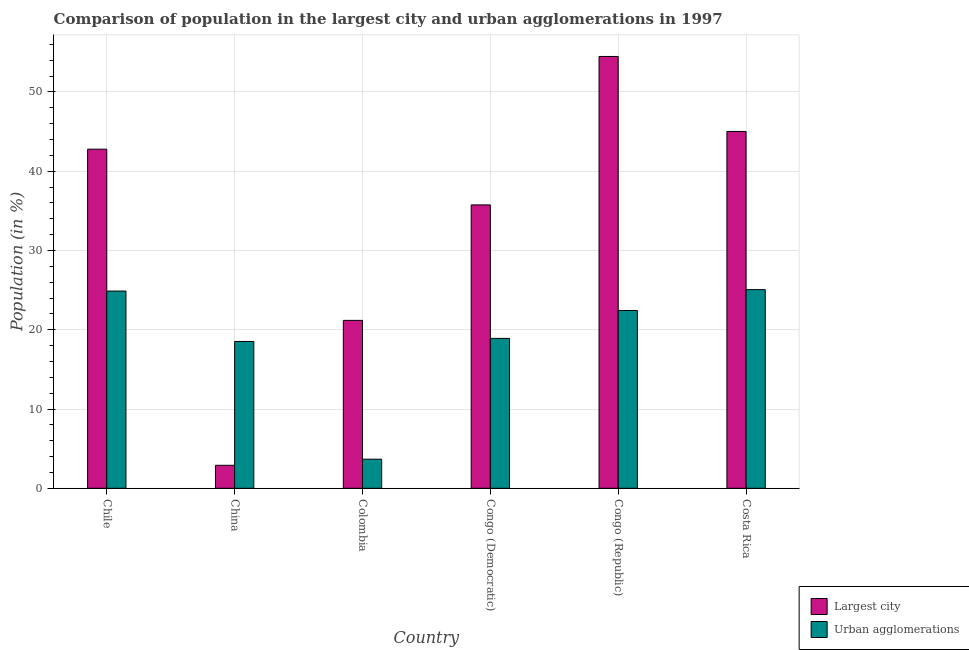Are the number of bars on each tick of the X-axis equal?
Keep it short and to the point. Yes. How many bars are there on the 6th tick from the right?
Provide a succinct answer. 2. What is the label of the 5th group of bars from the left?
Keep it short and to the point. Congo (Republic). In how many cases, is the number of bars for a given country not equal to the number of legend labels?
Your response must be concise. 0. What is the population in the largest city in Chile?
Ensure brevity in your answer.  42.78. Across all countries, what is the maximum population in urban agglomerations?
Ensure brevity in your answer.  25.06. Across all countries, what is the minimum population in the largest city?
Give a very brief answer. 2.9. In which country was the population in urban agglomerations maximum?
Ensure brevity in your answer.  Costa Rica. In which country was the population in urban agglomerations minimum?
Your response must be concise. Colombia. What is the total population in urban agglomerations in the graph?
Offer a very short reply. 113.47. What is the difference between the population in the largest city in Congo (Democratic) and that in Costa Rica?
Provide a succinct answer. -9.27. What is the difference between the population in the largest city in China and the population in urban agglomerations in Chile?
Offer a very short reply. -21.98. What is the average population in urban agglomerations per country?
Your answer should be compact. 18.91. What is the difference between the population in urban agglomerations and population in the largest city in Costa Rica?
Keep it short and to the point. -19.95. What is the ratio of the population in urban agglomerations in Congo (Democratic) to that in Costa Rica?
Keep it short and to the point. 0.75. Is the population in the largest city in Colombia less than that in Costa Rica?
Give a very brief answer. Yes. Is the difference between the population in the largest city in Chile and China greater than the difference between the population in urban agglomerations in Chile and China?
Your answer should be compact. Yes. What is the difference between the highest and the second highest population in urban agglomerations?
Provide a succinct answer. 0.18. What is the difference between the highest and the lowest population in the largest city?
Your answer should be very brief. 51.57. In how many countries, is the population in urban agglomerations greater than the average population in urban agglomerations taken over all countries?
Provide a succinct answer. 3. What does the 2nd bar from the left in Chile represents?
Your response must be concise. Urban agglomerations. What does the 2nd bar from the right in Congo (Republic) represents?
Your answer should be very brief. Largest city. How many bars are there?
Give a very brief answer. 12. Are all the bars in the graph horizontal?
Ensure brevity in your answer.  No. How many countries are there in the graph?
Your response must be concise. 6. What is the difference between two consecutive major ticks on the Y-axis?
Provide a short and direct response. 10. Are the values on the major ticks of Y-axis written in scientific E-notation?
Keep it short and to the point. No. Does the graph contain any zero values?
Offer a terse response. No. Where does the legend appear in the graph?
Offer a terse response. Bottom right. How many legend labels are there?
Provide a short and direct response. 2. How are the legend labels stacked?
Offer a terse response. Vertical. What is the title of the graph?
Ensure brevity in your answer.  Comparison of population in the largest city and urban agglomerations in 1997. Does "Formally registered" appear as one of the legend labels in the graph?
Your answer should be very brief. No. What is the Population (in %) in Largest city in Chile?
Provide a succinct answer. 42.78. What is the Population (in %) in Urban agglomerations in Chile?
Your answer should be compact. 24.88. What is the Population (in %) in Largest city in China?
Your response must be concise. 2.9. What is the Population (in %) in Urban agglomerations in China?
Your response must be concise. 18.52. What is the Population (in %) of Largest city in Colombia?
Provide a succinct answer. 21.18. What is the Population (in %) of Urban agglomerations in Colombia?
Ensure brevity in your answer.  3.67. What is the Population (in %) of Largest city in Congo (Democratic)?
Offer a terse response. 35.75. What is the Population (in %) of Urban agglomerations in Congo (Democratic)?
Keep it short and to the point. 18.91. What is the Population (in %) in Largest city in Congo (Republic)?
Provide a succinct answer. 54.47. What is the Population (in %) in Urban agglomerations in Congo (Republic)?
Make the answer very short. 22.43. What is the Population (in %) of Largest city in Costa Rica?
Your answer should be compact. 45.01. What is the Population (in %) of Urban agglomerations in Costa Rica?
Keep it short and to the point. 25.06. Across all countries, what is the maximum Population (in %) of Largest city?
Provide a succinct answer. 54.47. Across all countries, what is the maximum Population (in %) of Urban agglomerations?
Your answer should be compact. 25.06. Across all countries, what is the minimum Population (in %) of Largest city?
Your answer should be compact. 2.9. Across all countries, what is the minimum Population (in %) in Urban agglomerations?
Offer a very short reply. 3.67. What is the total Population (in %) of Largest city in the graph?
Ensure brevity in your answer.  202.1. What is the total Population (in %) in Urban agglomerations in the graph?
Ensure brevity in your answer.  113.47. What is the difference between the Population (in %) of Largest city in Chile and that in China?
Provide a succinct answer. 39.88. What is the difference between the Population (in %) of Urban agglomerations in Chile and that in China?
Ensure brevity in your answer.  6.36. What is the difference between the Population (in %) in Largest city in Chile and that in Colombia?
Your answer should be compact. 21.6. What is the difference between the Population (in %) of Urban agglomerations in Chile and that in Colombia?
Your answer should be compact. 21.21. What is the difference between the Population (in %) in Largest city in Chile and that in Congo (Democratic)?
Provide a short and direct response. 7.03. What is the difference between the Population (in %) of Urban agglomerations in Chile and that in Congo (Democratic)?
Make the answer very short. 5.97. What is the difference between the Population (in %) of Largest city in Chile and that in Congo (Republic)?
Your answer should be compact. -11.7. What is the difference between the Population (in %) of Urban agglomerations in Chile and that in Congo (Republic)?
Ensure brevity in your answer.  2.45. What is the difference between the Population (in %) in Largest city in Chile and that in Costa Rica?
Provide a succinct answer. -2.24. What is the difference between the Population (in %) in Urban agglomerations in Chile and that in Costa Rica?
Ensure brevity in your answer.  -0.18. What is the difference between the Population (in %) of Largest city in China and that in Colombia?
Ensure brevity in your answer.  -18.28. What is the difference between the Population (in %) in Urban agglomerations in China and that in Colombia?
Make the answer very short. 14.85. What is the difference between the Population (in %) in Largest city in China and that in Congo (Democratic)?
Offer a very short reply. -32.85. What is the difference between the Population (in %) in Urban agglomerations in China and that in Congo (Democratic)?
Give a very brief answer. -0.39. What is the difference between the Population (in %) in Largest city in China and that in Congo (Republic)?
Provide a short and direct response. -51.57. What is the difference between the Population (in %) of Urban agglomerations in China and that in Congo (Republic)?
Give a very brief answer. -3.91. What is the difference between the Population (in %) in Largest city in China and that in Costa Rica?
Your response must be concise. -42.11. What is the difference between the Population (in %) in Urban agglomerations in China and that in Costa Rica?
Make the answer very short. -6.54. What is the difference between the Population (in %) in Largest city in Colombia and that in Congo (Democratic)?
Ensure brevity in your answer.  -14.57. What is the difference between the Population (in %) of Urban agglomerations in Colombia and that in Congo (Democratic)?
Provide a succinct answer. -15.24. What is the difference between the Population (in %) in Largest city in Colombia and that in Congo (Republic)?
Your response must be concise. -33.29. What is the difference between the Population (in %) in Urban agglomerations in Colombia and that in Congo (Republic)?
Your response must be concise. -18.76. What is the difference between the Population (in %) of Largest city in Colombia and that in Costa Rica?
Keep it short and to the point. -23.83. What is the difference between the Population (in %) in Urban agglomerations in Colombia and that in Costa Rica?
Ensure brevity in your answer.  -21.39. What is the difference between the Population (in %) in Largest city in Congo (Democratic) and that in Congo (Republic)?
Offer a very short reply. -18.73. What is the difference between the Population (in %) in Urban agglomerations in Congo (Democratic) and that in Congo (Republic)?
Ensure brevity in your answer.  -3.52. What is the difference between the Population (in %) in Largest city in Congo (Democratic) and that in Costa Rica?
Make the answer very short. -9.27. What is the difference between the Population (in %) of Urban agglomerations in Congo (Democratic) and that in Costa Rica?
Offer a very short reply. -6.15. What is the difference between the Population (in %) in Largest city in Congo (Republic) and that in Costa Rica?
Give a very brief answer. 9.46. What is the difference between the Population (in %) in Urban agglomerations in Congo (Republic) and that in Costa Rica?
Offer a very short reply. -2.63. What is the difference between the Population (in %) in Largest city in Chile and the Population (in %) in Urban agglomerations in China?
Ensure brevity in your answer.  24.26. What is the difference between the Population (in %) in Largest city in Chile and the Population (in %) in Urban agglomerations in Colombia?
Ensure brevity in your answer.  39.11. What is the difference between the Population (in %) of Largest city in Chile and the Population (in %) of Urban agglomerations in Congo (Democratic)?
Your response must be concise. 23.87. What is the difference between the Population (in %) of Largest city in Chile and the Population (in %) of Urban agglomerations in Congo (Republic)?
Provide a succinct answer. 20.35. What is the difference between the Population (in %) of Largest city in Chile and the Population (in %) of Urban agglomerations in Costa Rica?
Offer a terse response. 17.72. What is the difference between the Population (in %) of Largest city in China and the Population (in %) of Urban agglomerations in Colombia?
Offer a terse response. -0.77. What is the difference between the Population (in %) of Largest city in China and the Population (in %) of Urban agglomerations in Congo (Democratic)?
Keep it short and to the point. -16.01. What is the difference between the Population (in %) of Largest city in China and the Population (in %) of Urban agglomerations in Congo (Republic)?
Your answer should be compact. -19.53. What is the difference between the Population (in %) in Largest city in China and the Population (in %) in Urban agglomerations in Costa Rica?
Make the answer very short. -22.16. What is the difference between the Population (in %) in Largest city in Colombia and the Population (in %) in Urban agglomerations in Congo (Democratic)?
Ensure brevity in your answer.  2.27. What is the difference between the Population (in %) in Largest city in Colombia and the Population (in %) in Urban agglomerations in Congo (Republic)?
Keep it short and to the point. -1.25. What is the difference between the Population (in %) in Largest city in Colombia and the Population (in %) in Urban agglomerations in Costa Rica?
Your answer should be very brief. -3.88. What is the difference between the Population (in %) of Largest city in Congo (Democratic) and the Population (in %) of Urban agglomerations in Congo (Republic)?
Ensure brevity in your answer.  13.32. What is the difference between the Population (in %) of Largest city in Congo (Democratic) and the Population (in %) of Urban agglomerations in Costa Rica?
Give a very brief answer. 10.69. What is the difference between the Population (in %) in Largest city in Congo (Republic) and the Population (in %) in Urban agglomerations in Costa Rica?
Keep it short and to the point. 29.41. What is the average Population (in %) in Largest city per country?
Make the answer very short. 33.68. What is the average Population (in %) of Urban agglomerations per country?
Keep it short and to the point. 18.91. What is the difference between the Population (in %) of Largest city and Population (in %) of Urban agglomerations in Chile?
Your answer should be compact. 17.9. What is the difference between the Population (in %) of Largest city and Population (in %) of Urban agglomerations in China?
Your answer should be compact. -15.62. What is the difference between the Population (in %) in Largest city and Population (in %) in Urban agglomerations in Colombia?
Give a very brief answer. 17.51. What is the difference between the Population (in %) of Largest city and Population (in %) of Urban agglomerations in Congo (Democratic)?
Your response must be concise. 16.84. What is the difference between the Population (in %) in Largest city and Population (in %) in Urban agglomerations in Congo (Republic)?
Offer a terse response. 32.04. What is the difference between the Population (in %) in Largest city and Population (in %) in Urban agglomerations in Costa Rica?
Your answer should be very brief. 19.95. What is the ratio of the Population (in %) in Largest city in Chile to that in China?
Make the answer very short. 14.75. What is the ratio of the Population (in %) in Urban agglomerations in Chile to that in China?
Give a very brief answer. 1.34. What is the ratio of the Population (in %) in Largest city in Chile to that in Colombia?
Offer a very short reply. 2.02. What is the ratio of the Population (in %) of Urban agglomerations in Chile to that in Colombia?
Make the answer very short. 6.78. What is the ratio of the Population (in %) in Largest city in Chile to that in Congo (Democratic)?
Offer a terse response. 1.2. What is the ratio of the Population (in %) of Urban agglomerations in Chile to that in Congo (Democratic)?
Give a very brief answer. 1.32. What is the ratio of the Population (in %) of Largest city in Chile to that in Congo (Republic)?
Provide a succinct answer. 0.79. What is the ratio of the Population (in %) of Urban agglomerations in Chile to that in Congo (Republic)?
Your response must be concise. 1.11. What is the ratio of the Population (in %) in Largest city in Chile to that in Costa Rica?
Ensure brevity in your answer.  0.95. What is the ratio of the Population (in %) of Largest city in China to that in Colombia?
Keep it short and to the point. 0.14. What is the ratio of the Population (in %) of Urban agglomerations in China to that in Colombia?
Offer a terse response. 5.05. What is the ratio of the Population (in %) of Largest city in China to that in Congo (Democratic)?
Offer a very short reply. 0.08. What is the ratio of the Population (in %) in Urban agglomerations in China to that in Congo (Democratic)?
Ensure brevity in your answer.  0.98. What is the ratio of the Population (in %) of Largest city in China to that in Congo (Republic)?
Make the answer very short. 0.05. What is the ratio of the Population (in %) in Urban agglomerations in China to that in Congo (Republic)?
Provide a short and direct response. 0.83. What is the ratio of the Population (in %) in Largest city in China to that in Costa Rica?
Your answer should be compact. 0.06. What is the ratio of the Population (in %) in Urban agglomerations in China to that in Costa Rica?
Make the answer very short. 0.74. What is the ratio of the Population (in %) of Largest city in Colombia to that in Congo (Democratic)?
Ensure brevity in your answer.  0.59. What is the ratio of the Population (in %) in Urban agglomerations in Colombia to that in Congo (Democratic)?
Ensure brevity in your answer.  0.19. What is the ratio of the Population (in %) in Largest city in Colombia to that in Congo (Republic)?
Offer a terse response. 0.39. What is the ratio of the Population (in %) in Urban agglomerations in Colombia to that in Congo (Republic)?
Provide a short and direct response. 0.16. What is the ratio of the Population (in %) in Largest city in Colombia to that in Costa Rica?
Make the answer very short. 0.47. What is the ratio of the Population (in %) of Urban agglomerations in Colombia to that in Costa Rica?
Provide a short and direct response. 0.15. What is the ratio of the Population (in %) of Largest city in Congo (Democratic) to that in Congo (Republic)?
Your answer should be compact. 0.66. What is the ratio of the Population (in %) in Urban agglomerations in Congo (Democratic) to that in Congo (Republic)?
Your answer should be compact. 0.84. What is the ratio of the Population (in %) of Largest city in Congo (Democratic) to that in Costa Rica?
Make the answer very short. 0.79. What is the ratio of the Population (in %) of Urban agglomerations in Congo (Democratic) to that in Costa Rica?
Keep it short and to the point. 0.75. What is the ratio of the Population (in %) of Largest city in Congo (Republic) to that in Costa Rica?
Make the answer very short. 1.21. What is the ratio of the Population (in %) in Urban agglomerations in Congo (Republic) to that in Costa Rica?
Your answer should be compact. 0.9. What is the difference between the highest and the second highest Population (in %) in Largest city?
Your answer should be compact. 9.46. What is the difference between the highest and the second highest Population (in %) of Urban agglomerations?
Your response must be concise. 0.18. What is the difference between the highest and the lowest Population (in %) of Largest city?
Provide a succinct answer. 51.57. What is the difference between the highest and the lowest Population (in %) of Urban agglomerations?
Offer a terse response. 21.39. 